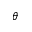<formula> <loc_0><loc_0><loc_500><loc_500>\theta</formula> 